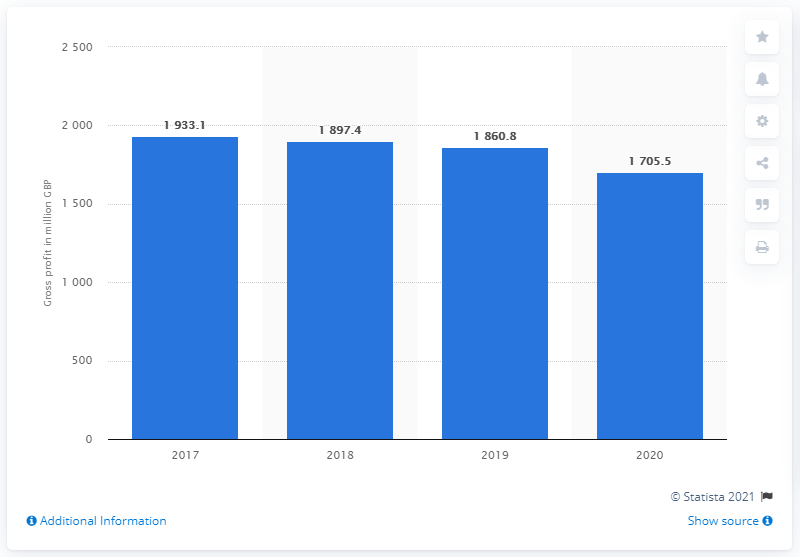List a handful of essential elements in this visual. Burberry's gross profit in 2020 was 1,705.5. 